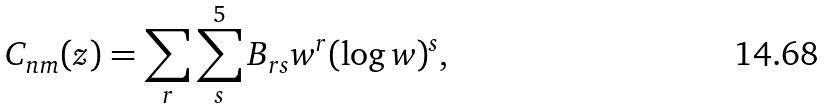Convert formula to latex. <formula><loc_0><loc_0><loc_500><loc_500>C _ { n m } ( z ) = \sum _ { r } \sum _ { s } ^ { 5 } B _ { r s } w ^ { r } ( \log { w } ) ^ { s } ,</formula> 